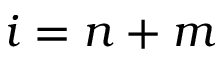<formula> <loc_0><loc_0><loc_500><loc_500>i = n + m</formula> 